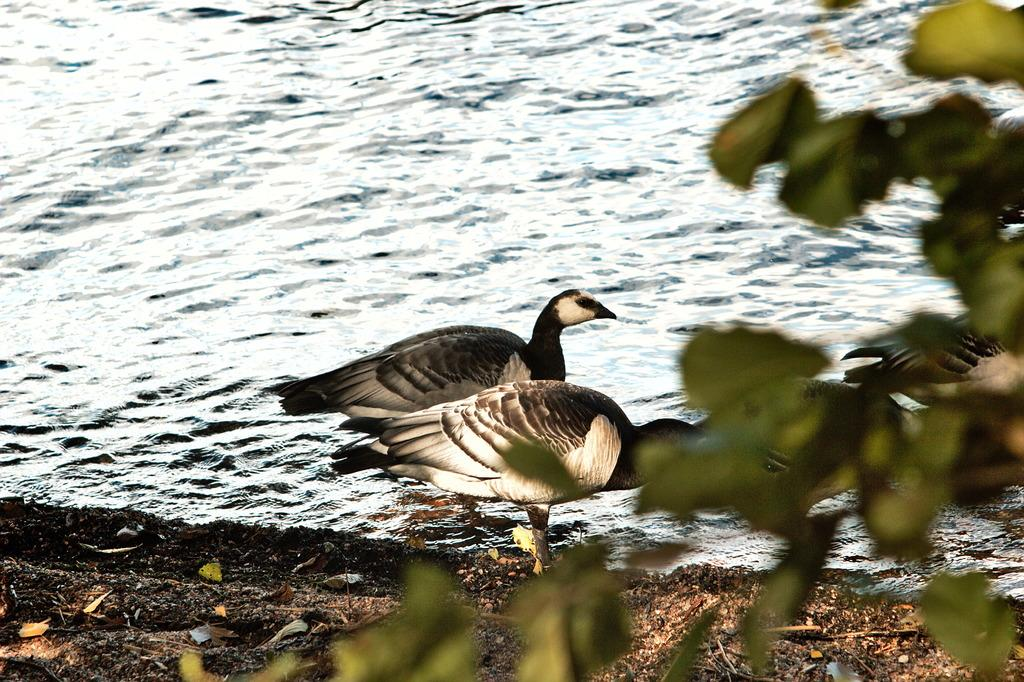What animals can be seen in the river in the image? There are two birds in the river in the center of the image. What is located on the left side of the image? There is a tree on the left side of the image. What can be seen in the background of the image? There is water visible in the background of the image. How many pies are being carried by the cart in the image? There is no cart or pies present in the image. What type of grip is required to hold the tree in the image? There is no need to grip the tree in the image, as it is a stationary object. 